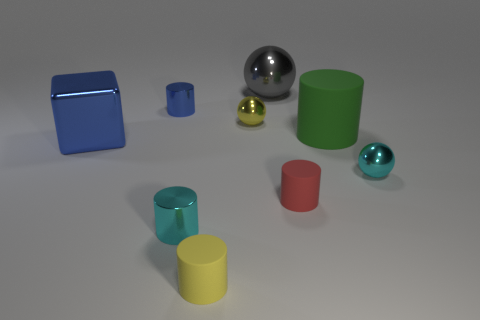Are there any other things that have the same shape as the large matte thing?
Offer a terse response. Yes. How many other things are there of the same size as the green object?
Make the answer very short. 2. Do the blue metallic thing that is in front of the small blue thing and the cyan object on the left side of the gray thing have the same size?
Ensure brevity in your answer.  No. How many objects are either small gray metallic balls or big metal things that are right of the small yellow rubber thing?
Offer a terse response. 1. There is a cyan shiny thing that is on the right side of the red matte cylinder; what size is it?
Keep it short and to the point. Small. Are there fewer large blue blocks that are behind the green rubber cylinder than tiny red things that are behind the blue metal cylinder?
Your response must be concise. No. There is a large object that is in front of the large sphere and to the left of the big green cylinder; what is it made of?
Offer a very short reply. Metal. What is the shape of the blue object in front of the metal cylinder behind the blue cube?
Ensure brevity in your answer.  Cube. Does the big metallic ball have the same color as the big rubber cylinder?
Offer a very short reply. No. What number of green objects are either big matte cylinders or large metallic balls?
Your response must be concise. 1. 